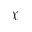Convert formula to latex. <formula><loc_0><loc_0><loc_500><loc_500>\mathcal { X }</formula> 